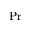<formula> <loc_0><loc_0><loc_500><loc_500>P r</formula> 